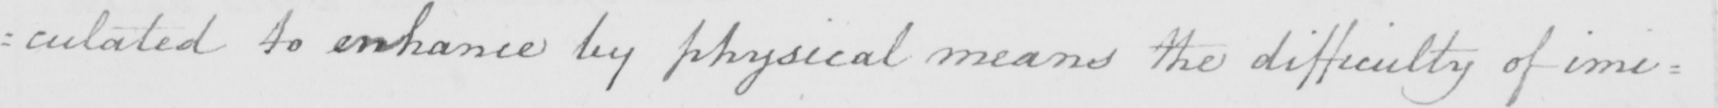What does this handwritten line say? : culated to enhance by physical means the difficulty of imi= 